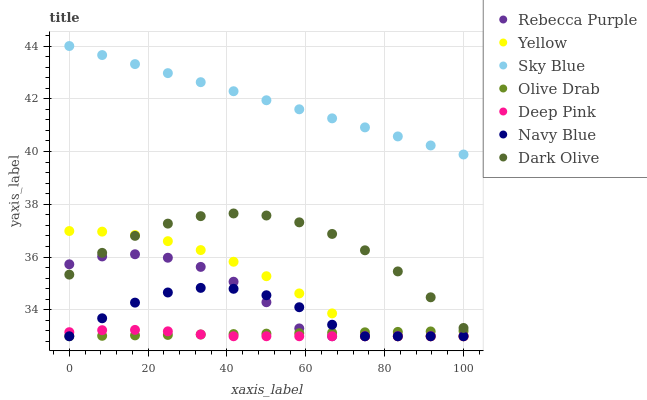Does Deep Pink have the minimum area under the curve?
Answer yes or no. Yes. Does Sky Blue have the maximum area under the curve?
Answer yes or no. Yes. Does Navy Blue have the minimum area under the curve?
Answer yes or no. No. Does Navy Blue have the maximum area under the curve?
Answer yes or no. No. Is Olive Drab the smoothest?
Answer yes or no. Yes. Is Rebecca Purple the roughest?
Answer yes or no. Yes. Is Navy Blue the smoothest?
Answer yes or no. No. Is Navy Blue the roughest?
Answer yes or no. No. Does Deep Pink have the lowest value?
Answer yes or no. Yes. Does Dark Olive have the lowest value?
Answer yes or no. No. Does Sky Blue have the highest value?
Answer yes or no. Yes. Does Navy Blue have the highest value?
Answer yes or no. No. Is Dark Olive less than Sky Blue?
Answer yes or no. Yes. Is Dark Olive greater than Olive Drab?
Answer yes or no. Yes. Does Yellow intersect Rebecca Purple?
Answer yes or no. Yes. Is Yellow less than Rebecca Purple?
Answer yes or no. No. Is Yellow greater than Rebecca Purple?
Answer yes or no. No. Does Dark Olive intersect Sky Blue?
Answer yes or no. No. 